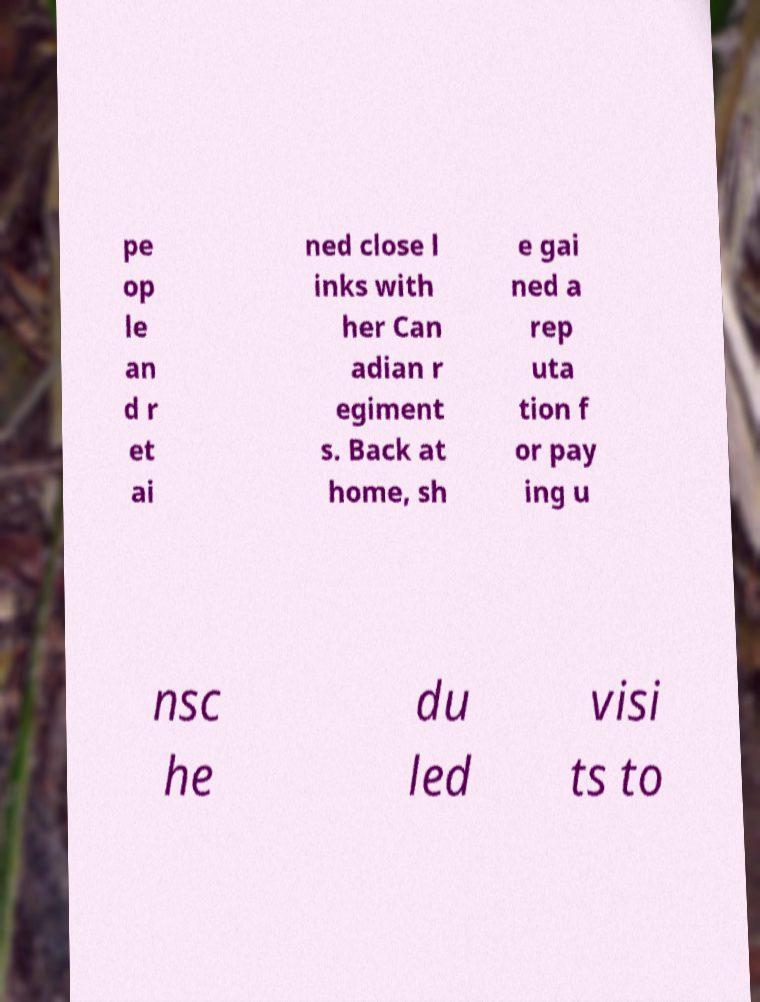I need the written content from this picture converted into text. Can you do that? pe op le an d r et ai ned close l inks with her Can adian r egiment s. Back at home, sh e gai ned a rep uta tion f or pay ing u nsc he du led visi ts to 